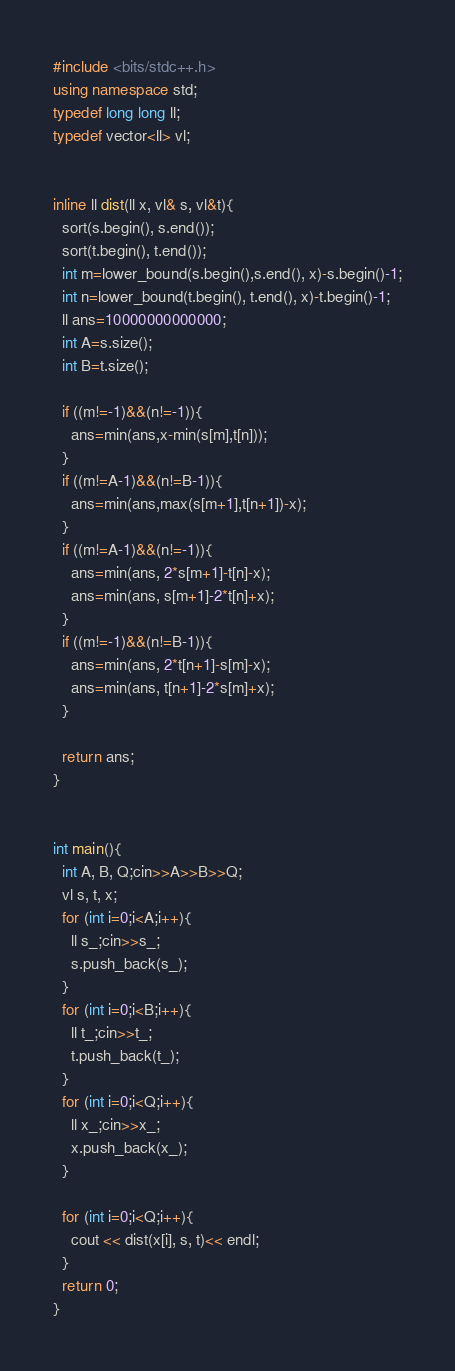<code> <loc_0><loc_0><loc_500><loc_500><_C++_>#include <bits/stdc++.h>
using namespace std;
typedef long long ll;
typedef vector<ll> vl;


inline ll dist(ll x, vl& s, vl&t){
  sort(s.begin(), s.end());
  sort(t.begin(), t.end());
  int m=lower_bound(s.begin(),s.end(), x)-s.begin()-1;
  int n=lower_bound(t.begin(), t.end(), x)-t.begin()-1;
  ll ans=10000000000000;
  int A=s.size();
  int B=t.size();
  
  if ((m!=-1)&&(n!=-1)){
    ans=min(ans,x-min(s[m],t[n]));
  }
  if ((m!=A-1)&&(n!=B-1)){
    ans=min(ans,max(s[m+1],t[n+1])-x);
  }
  if ((m!=A-1)&&(n!=-1)){
    ans=min(ans, 2*s[m+1]-t[n]-x);
    ans=min(ans, s[m+1]-2*t[n]+x);
  }
  if ((m!=-1)&&(n!=B-1)){
    ans=min(ans, 2*t[n+1]-s[m]-x);
    ans=min(ans, t[n+1]-2*s[m]+x);
  }
  
  return ans;
}


int main(){
  int A, B, Q;cin>>A>>B>>Q;
  vl s, t, x;
  for (int i=0;i<A;i++){
    ll s_;cin>>s_;
    s.push_back(s_);
  }
  for (int i=0;i<B;i++){
    ll t_;cin>>t_;
    t.push_back(t_);
  }
  for (int i=0;i<Q;i++){
    ll x_;cin>>x_;
    x.push_back(x_);
  }

  for (int i=0;i<Q;i++){
    cout << dist(x[i], s, t)<< endl;
  }
  return 0;
}</code> 